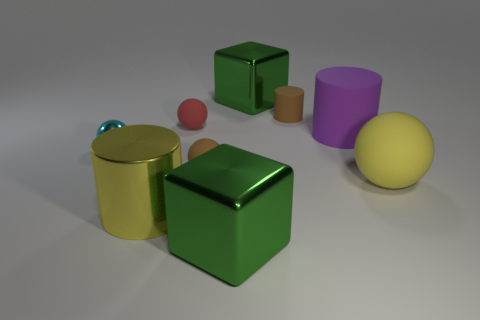There is a large object that is the same color as the large ball; what is its material?
Provide a succinct answer. Metal. What is the size of the object that is the same color as the small rubber cylinder?
Give a very brief answer. Small. There is a yellow thing that is made of the same material as the small brown sphere; what shape is it?
Ensure brevity in your answer.  Sphere. Is there anything else that has the same color as the shiny ball?
Offer a very short reply. No. Is the number of objects right of the red matte thing greater than the number of small cylinders that are behind the large purple rubber thing?
Your answer should be very brief. Yes. What number of cyan shiny objects have the same size as the red rubber object?
Offer a very short reply. 1. Are there fewer tiny brown rubber objects left of the small brown cylinder than rubber cylinders that are on the right side of the tiny brown sphere?
Provide a succinct answer. Yes. Are there any big green metallic things of the same shape as the purple matte thing?
Keep it short and to the point. No. Is the small metallic object the same shape as the yellow matte thing?
Ensure brevity in your answer.  Yes. How many big things are either metallic objects or brown matte things?
Offer a very short reply. 3. 